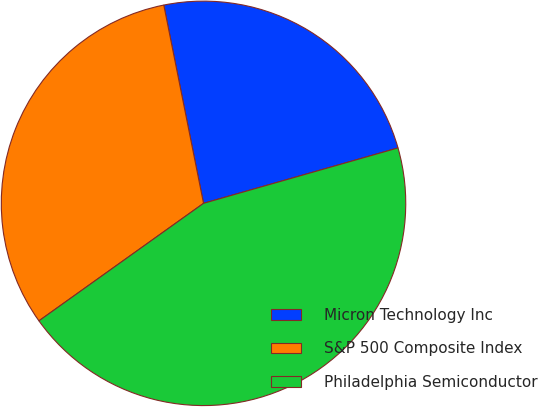Convert chart to OTSL. <chart><loc_0><loc_0><loc_500><loc_500><pie_chart><fcel>Micron Technology Inc<fcel>S&P 500 Composite Index<fcel>Philadelphia Semiconductor<nl><fcel>23.73%<fcel>31.72%<fcel>44.55%<nl></chart> 